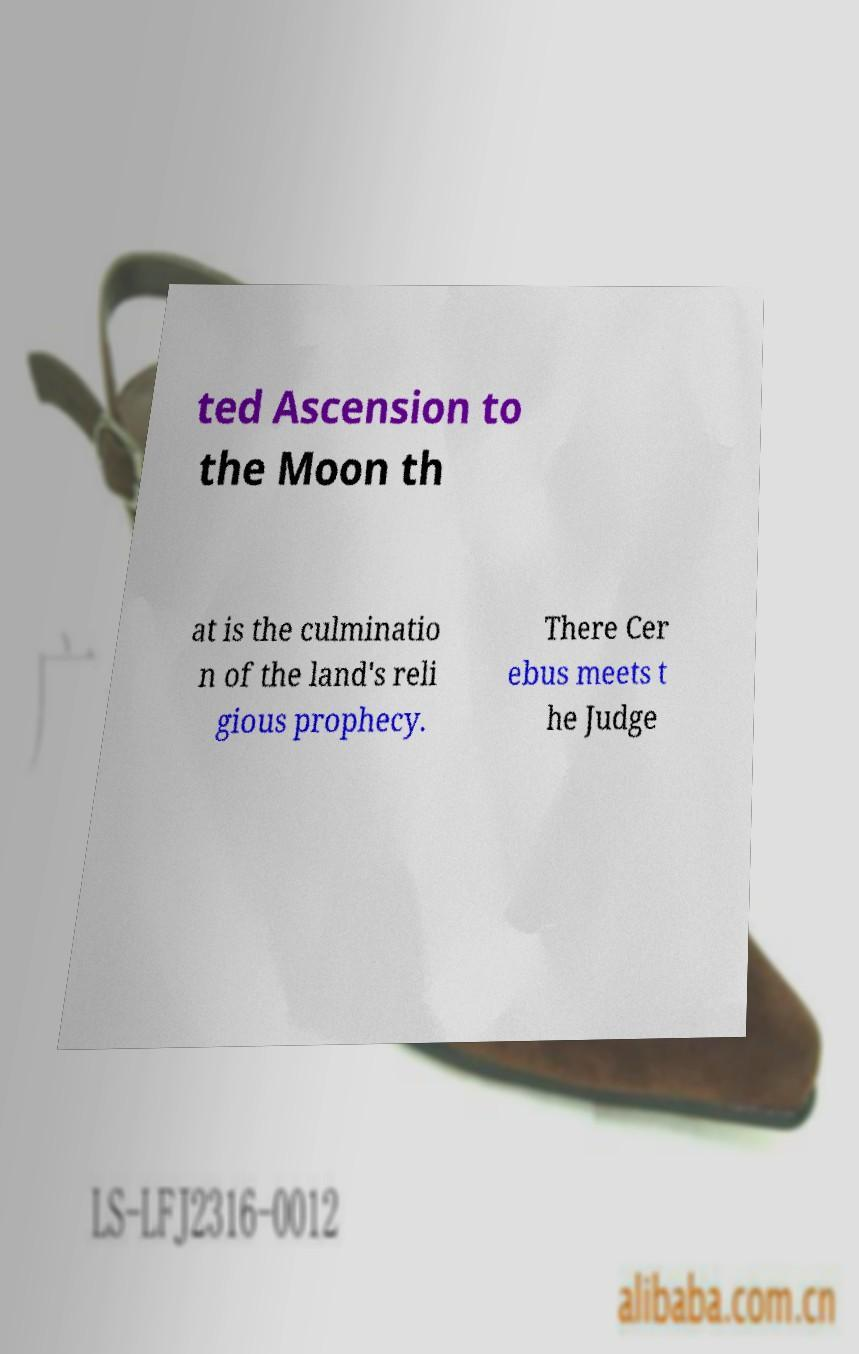Can you accurately transcribe the text from the provided image for me? ted Ascension to the Moon th at is the culminatio n of the land's reli gious prophecy. There Cer ebus meets t he Judge 